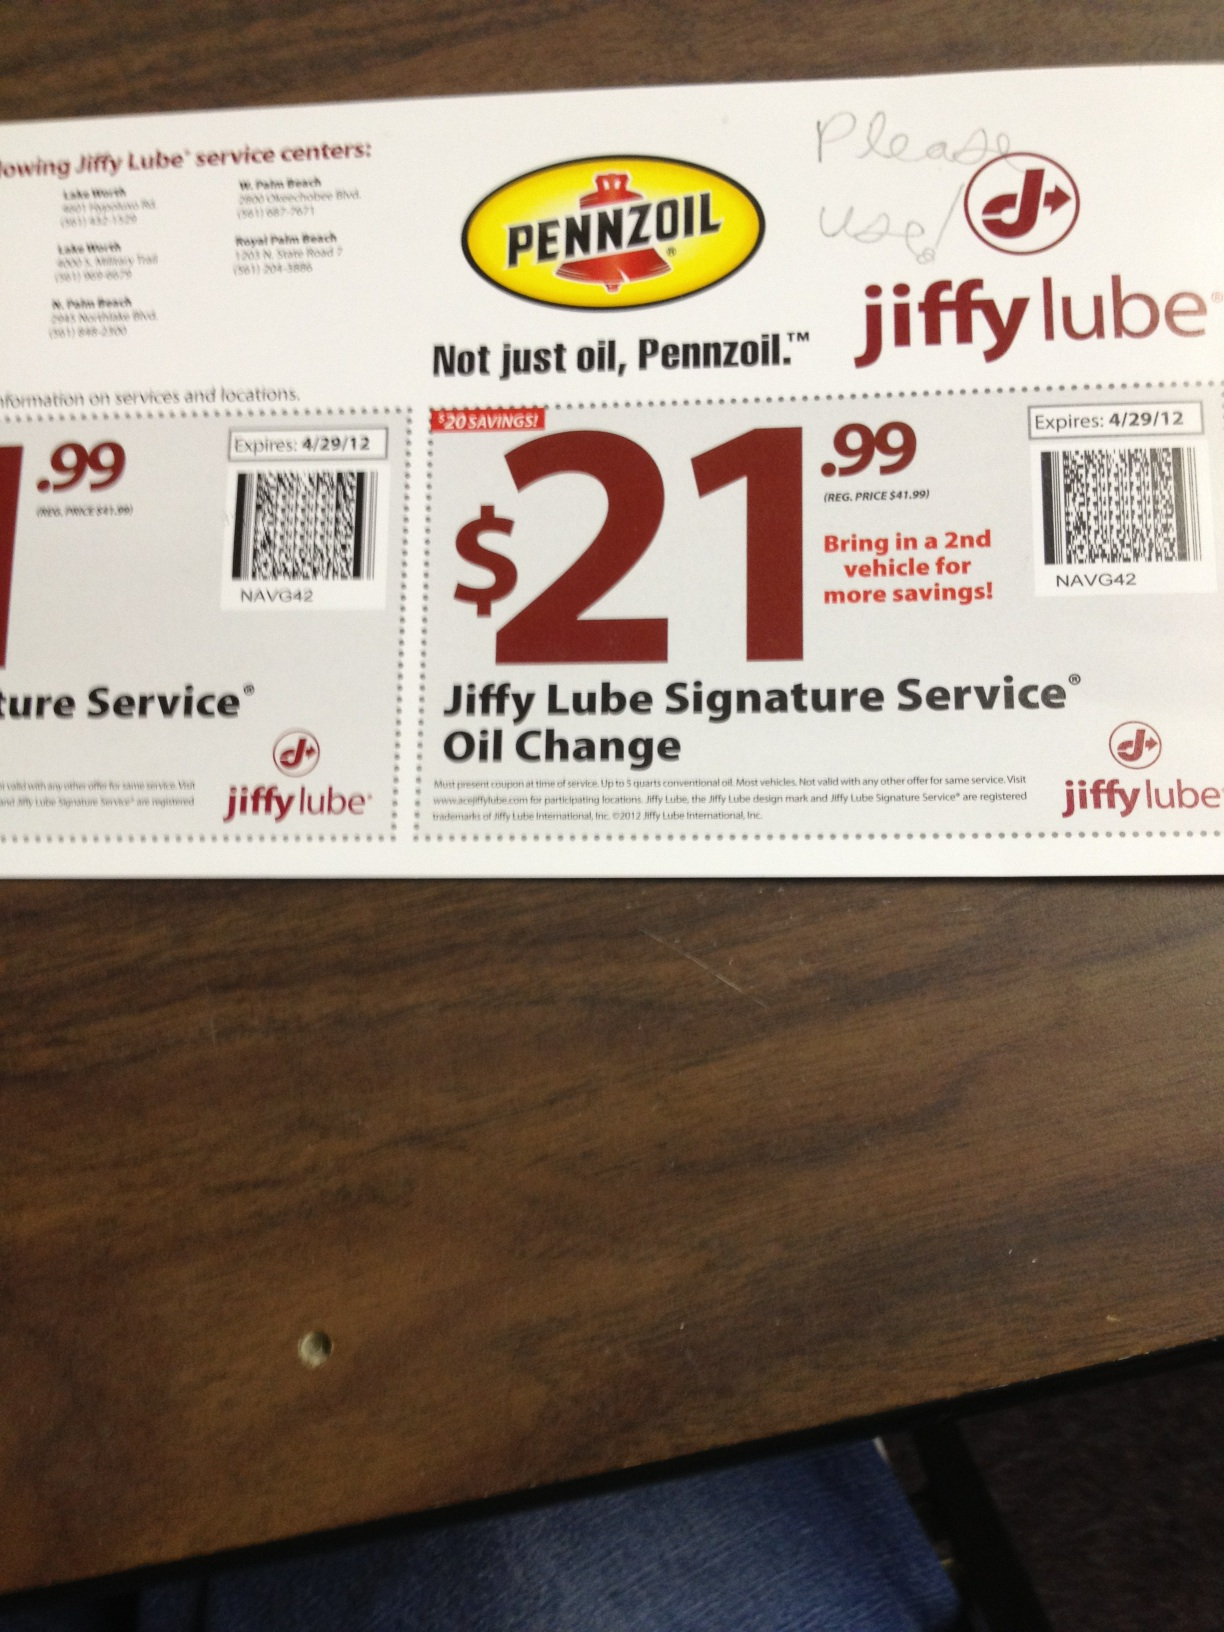Provide a short response on how to redeem this coupon. To redeem this coupon, simply present it at a participating Jiffy Lube service center before the expiration date. 